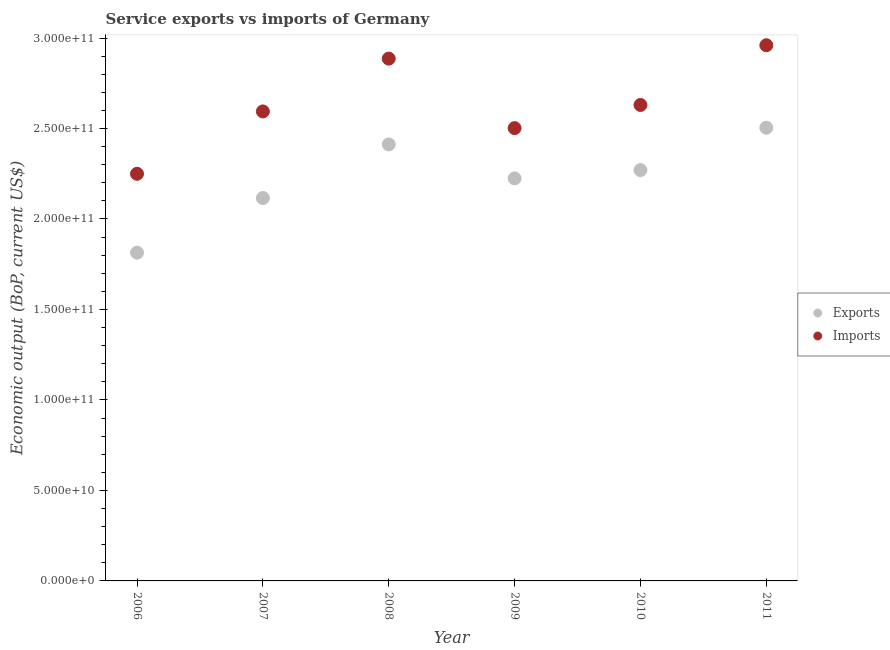How many different coloured dotlines are there?
Offer a terse response. 2. Is the number of dotlines equal to the number of legend labels?
Keep it short and to the point. Yes. What is the amount of service exports in 2010?
Your response must be concise. 2.27e+11. Across all years, what is the maximum amount of service exports?
Provide a short and direct response. 2.50e+11. Across all years, what is the minimum amount of service exports?
Provide a short and direct response. 1.81e+11. What is the total amount of service exports in the graph?
Make the answer very short. 1.33e+12. What is the difference between the amount of service exports in 2007 and that in 2008?
Your response must be concise. -2.96e+1. What is the difference between the amount of service imports in 2010 and the amount of service exports in 2009?
Provide a succinct answer. 4.06e+1. What is the average amount of service exports per year?
Keep it short and to the point. 2.22e+11. In the year 2010, what is the difference between the amount of service exports and amount of service imports?
Make the answer very short. -3.60e+1. What is the ratio of the amount of service exports in 2009 to that in 2010?
Provide a succinct answer. 0.98. Is the amount of service imports in 2006 less than that in 2009?
Offer a very short reply. Yes. What is the difference between the highest and the second highest amount of service imports?
Ensure brevity in your answer.  7.39e+09. What is the difference between the highest and the lowest amount of service exports?
Your answer should be compact. 6.91e+1. Is the sum of the amount of service exports in 2007 and 2009 greater than the maximum amount of service imports across all years?
Ensure brevity in your answer.  Yes. Does the graph contain grids?
Your answer should be compact. No. How many legend labels are there?
Offer a terse response. 2. How are the legend labels stacked?
Offer a terse response. Vertical. What is the title of the graph?
Your answer should be compact. Service exports vs imports of Germany. What is the label or title of the Y-axis?
Your response must be concise. Economic output (BoP, current US$). What is the Economic output (BoP, current US$) in Exports in 2006?
Provide a short and direct response. 1.81e+11. What is the Economic output (BoP, current US$) of Imports in 2006?
Ensure brevity in your answer.  2.25e+11. What is the Economic output (BoP, current US$) in Exports in 2007?
Provide a succinct answer. 2.12e+11. What is the Economic output (BoP, current US$) of Imports in 2007?
Offer a terse response. 2.59e+11. What is the Economic output (BoP, current US$) of Exports in 2008?
Provide a short and direct response. 2.41e+11. What is the Economic output (BoP, current US$) of Imports in 2008?
Your answer should be compact. 2.89e+11. What is the Economic output (BoP, current US$) in Exports in 2009?
Your response must be concise. 2.22e+11. What is the Economic output (BoP, current US$) of Imports in 2009?
Provide a short and direct response. 2.50e+11. What is the Economic output (BoP, current US$) of Exports in 2010?
Offer a very short reply. 2.27e+11. What is the Economic output (BoP, current US$) of Imports in 2010?
Make the answer very short. 2.63e+11. What is the Economic output (BoP, current US$) in Exports in 2011?
Make the answer very short. 2.50e+11. What is the Economic output (BoP, current US$) of Imports in 2011?
Provide a succinct answer. 2.96e+11. Across all years, what is the maximum Economic output (BoP, current US$) of Exports?
Make the answer very short. 2.50e+11. Across all years, what is the maximum Economic output (BoP, current US$) of Imports?
Your answer should be compact. 2.96e+11. Across all years, what is the minimum Economic output (BoP, current US$) in Exports?
Ensure brevity in your answer.  1.81e+11. Across all years, what is the minimum Economic output (BoP, current US$) of Imports?
Your answer should be very brief. 2.25e+11. What is the total Economic output (BoP, current US$) in Exports in the graph?
Provide a succinct answer. 1.33e+12. What is the total Economic output (BoP, current US$) of Imports in the graph?
Your answer should be very brief. 1.58e+12. What is the difference between the Economic output (BoP, current US$) of Exports in 2006 and that in 2007?
Make the answer very short. -3.02e+1. What is the difference between the Economic output (BoP, current US$) of Imports in 2006 and that in 2007?
Provide a short and direct response. -3.45e+1. What is the difference between the Economic output (BoP, current US$) in Exports in 2006 and that in 2008?
Ensure brevity in your answer.  -5.98e+1. What is the difference between the Economic output (BoP, current US$) of Imports in 2006 and that in 2008?
Your answer should be compact. -6.36e+1. What is the difference between the Economic output (BoP, current US$) of Exports in 2006 and that in 2009?
Keep it short and to the point. -4.11e+1. What is the difference between the Economic output (BoP, current US$) in Imports in 2006 and that in 2009?
Your answer should be very brief. -2.52e+1. What is the difference between the Economic output (BoP, current US$) in Exports in 2006 and that in 2010?
Offer a terse response. -4.56e+1. What is the difference between the Economic output (BoP, current US$) in Imports in 2006 and that in 2010?
Ensure brevity in your answer.  -3.80e+1. What is the difference between the Economic output (BoP, current US$) of Exports in 2006 and that in 2011?
Your answer should be very brief. -6.91e+1. What is the difference between the Economic output (BoP, current US$) of Imports in 2006 and that in 2011?
Give a very brief answer. -7.10e+1. What is the difference between the Economic output (BoP, current US$) in Exports in 2007 and that in 2008?
Your answer should be compact. -2.96e+1. What is the difference between the Economic output (BoP, current US$) of Imports in 2007 and that in 2008?
Your answer should be very brief. -2.92e+1. What is the difference between the Economic output (BoP, current US$) of Exports in 2007 and that in 2009?
Your response must be concise. -1.09e+1. What is the difference between the Economic output (BoP, current US$) in Imports in 2007 and that in 2009?
Make the answer very short. 9.21e+09. What is the difference between the Economic output (BoP, current US$) in Exports in 2007 and that in 2010?
Offer a very short reply. -1.54e+1. What is the difference between the Economic output (BoP, current US$) in Imports in 2007 and that in 2010?
Keep it short and to the point. -3.58e+09. What is the difference between the Economic output (BoP, current US$) of Exports in 2007 and that in 2011?
Your answer should be very brief. -3.88e+1. What is the difference between the Economic output (BoP, current US$) in Imports in 2007 and that in 2011?
Offer a very short reply. -3.66e+1. What is the difference between the Economic output (BoP, current US$) in Exports in 2008 and that in 2009?
Offer a terse response. 1.88e+1. What is the difference between the Economic output (BoP, current US$) of Imports in 2008 and that in 2009?
Give a very brief answer. 3.84e+1. What is the difference between the Economic output (BoP, current US$) of Exports in 2008 and that in 2010?
Your response must be concise. 1.42e+1. What is the difference between the Economic output (BoP, current US$) of Imports in 2008 and that in 2010?
Your answer should be compact. 2.56e+1. What is the difference between the Economic output (BoP, current US$) in Exports in 2008 and that in 2011?
Your response must be concise. -9.24e+09. What is the difference between the Economic output (BoP, current US$) in Imports in 2008 and that in 2011?
Your response must be concise. -7.39e+09. What is the difference between the Economic output (BoP, current US$) in Exports in 2009 and that in 2010?
Your answer should be very brief. -4.57e+09. What is the difference between the Economic output (BoP, current US$) of Imports in 2009 and that in 2010?
Offer a very short reply. -1.28e+1. What is the difference between the Economic output (BoP, current US$) of Exports in 2009 and that in 2011?
Give a very brief answer. -2.80e+1. What is the difference between the Economic output (BoP, current US$) in Imports in 2009 and that in 2011?
Offer a very short reply. -4.58e+1. What is the difference between the Economic output (BoP, current US$) in Exports in 2010 and that in 2011?
Your response must be concise. -2.34e+1. What is the difference between the Economic output (BoP, current US$) of Imports in 2010 and that in 2011?
Offer a very short reply. -3.30e+1. What is the difference between the Economic output (BoP, current US$) of Exports in 2006 and the Economic output (BoP, current US$) of Imports in 2007?
Give a very brief answer. -7.80e+1. What is the difference between the Economic output (BoP, current US$) of Exports in 2006 and the Economic output (BoP, current US$) of Imports in 2008?
Give a very brief answer. -1.07e+11. What is the difference between the Economic output (BoP, current US$) in Exports in 2006 and the Economic output (BoP, current US$) in Imports in 2009?
Your answer should be compact. -6.88e+1. What is the difference between the Economic output (BoP, current US$) of Exports in 2006 and the Economic output (BoP, current US$) of Imports in 2010?
Your answer should be very brief. -8.16e+1. What is the difference between the Economic output (BoP, current US$) in Exports in 2006 and the Economic output (BoP, current US$) in Imports in 2011?
Make the answer very short. -1.15e+11. What is the difference between the Economic output (BoP, current US$) in Exports in 2007 and the Economic output (BoP, current US$) in Imports in 2008?
Your answer should be very brief. -7.70e+1. What is the difference between the Economic output (BoP, current US$) of Exports in 2007 and the Economic output (BoP, current US$) of Imports in 2009?
Make the answer very short. -3.86e+1. What is the difference between the Economic output (BoP, current US$) in Exports in 2007 and the Economic output (BoP, current US$) in Imports in 2010?
Your answer should be very brief. -5.14e+1. What is the difference between the Economic output (BoP, current US$) in Exports in 2007 and the Economic output (BoP, current US$) in Imports in 2011?
Your answer should be compact. -8.44e+1. What is the difference between the Economic output (BoP, current US$) of Exports in 2008 and the Economic output (BoP, current US$) of Imports in 2009?
Keep it short and to the point. -9.02e+09. What is the difference between the Economic output (BoP, current US$) of Exports in 2008 and the Economic output (BoP, current US$) of Imports in 2010?
Give a very brief answer. -2.18e+1. What is the difference between the Economic output (BoP, current US$) of Exports in 2008 and the Economic output (BoP, current US$) of Imports in 2011?
Your answer should be very brief. -5.48e+1. What is the difference between the Economic output (BoP, current US$) of Exports in 2009 and the Economic output (BoP, current US$) of Imports in 2010?
Make the answer very short. -4.06e+1. What is the difference between the Economic output (BoP, current US$) in Exports in 2009 and the Economic output (BoP, current US$) in Imports in 2011?
Make the answer very short. -7.36e+1. What is the difference between the Economic output (BoP, current US$) in Exports in 2010 and the Economic output (BoP, current US$) in Imports in 2011?
Your answer should be very brief. -6.90e+1. What is the average Economic output (BoP, current US$) in Exports per year?
Your response must be concise. 2.22e+11. What is the average Economic output (BoP, current US$) in Imports per year?
Your answer should be very brief. 2.64e+11. In the year 2006, what is the difference between the Economic output (BoP, current US$) of Exports and Economic output (BoP, current US$) of Imports?
Your response must be concise. -4.36e+1. In the year 2007, what is the difference between the Economic output (BoP, current US$) in Exports and Economic output (BoP, current US$) in Imports?
Give a very brief answer. -4.78e+1. In the year 2008, what is the difference between the Economic output (BoP, current US$) of Exports and Economic output (BoP, current US$) of Imports?
Offer a very short reply. -4.74e+1. In the year 2009, what is the difference between the Economic output (BoP, current US$) in Exports and Economic output (BoP, current US$) in Imports?
Keep it short and to the point. -2.78e+1. In the year 2010, what is the difference between the Economic output (BoP, current US$) of Exports and Economic output (BoP, current US$) of Imports?
Ensure brevity in your answer.  -3.60e+1. In the year 2011, what is the difference between the Economic output (BoP, current US$) of Exports and Economic output (BoP, current US$) of Imports?
Your response must be concise. -4.56e+1. What is the ratio of the Economic output (BoP, current US$) in Exports in 2006 to that in 2007?
Provide a short and direct response. 0.86. What is the ratio of the Economic output (BoP, current US$) in Imports in 2006 to that in 2007?
Provide a succinct answer. 0.87. What is the ratio of the Economic output (BoP, current US$) in Exports in 2006 to that in 2008?
Your answer should be very brief. 0.75. What is the ratio of the Economic output (BoP, current US$) of Imports in 2006 to that in 2008?
Keep it short and to the point. 0.78. What is the ratio of the Economic output (BoP, current US$) of Exports in 2006 to that in 2009?
Keep it short and to the point. 0.82. What is the ratio of the Economic output (BoP, current US$) in Imports in 2006 to that in 2009?
Your response must be concise. 0.9. What is the ratio of the Economic output (BoP, current US$) in Exports in 2006 to that in 2010?
Your answer should be very brief. 0.8. What is the ratio of the Economic output (BoP, current US$) in Imports in 2006 to that in 2010?
Offer a very short reply. 0.86. What is the ratio of the Economic output (BoP, current US$) in Exports in 2006 to that in 2011?
Provide a short and direct response. 0.72. What is the ratio of the Economic output (BoP, current US$) in Imports in 2006 to that in 2011?
Give a very brief answer. 0.76. What is the ratio of the Economic output (BoP, current US$) of Exports in 2007 to that in 2008?
Make the answer very short. 0.88. What is the ratio of the Economic output (BoP, current US$) in Imports in 2007 to that in 2008?
Offer a very short reply. 0.9. What is the ratio of the Economic output (BoP, current US$) in Exports in 2007 to that in 2009?
Give a very brief answer. 0.95. What is the ratio of the Economic output (BoP, current US$) in Imports in 2007 to that in 2009?
Make the answer very short. 1.04. What is the ratio of the Economic output (BoP, current US$) in Exports in 2007 to that in 2010?
Your answer should be very brief. 0.93. What is the ratio of the Economic output (BoP, current US$) in Imports in 2007 to that in 2010?
Your answer should be compact. 0.99. What is the ratio of the Economic output (BoP, current US$) of Exports in 2007 to that in 2011?
Provide a short and direct response. 0.84. What is the ratio of the Economic output (BoP, current US$) in Imports in 2007 to that in 2011?
Make the answer very short. 0.88. What is the ratio of the Economic output (BoP, current US$) of Exports in 2008 to that in 2009?
Your response must be concise. 1.08. What is the ratio of the Economic output (BoP, current US$) in Imports in 2008 to that in 2009?
Offer a terse response. 1.15. What is the ratio of the Economic output (BoP, current US$) in Exports in 2008 to that in 2010?
Make the answer very short. 1.06. What is the ratio of the Economic output (BoP, current US$) of Imports in 2008 to that in 2010?
Provide a short and direct response. 1.1. What is the ratio of the Economic output (BoP, current US$) in Exports in 2008 to that in 2011?
Ensure brevity in your answer.  0.96. What is the ratio of the Economic output (BoP, current US$) in Exports in 2009 to that in 2010?
Provide a succinct answer. 0.98. What is the ratio of the Economic output (BoP, current US$) of Imports in 2009 to that in 2010?
Offer a terse response. 0.95. What is the ratio of the Economic output (BoP, current US$) in Exports in 2009 to that in 2011?
Make the answer very short. 0.89. What is the ratio of the Economic output (BoP, current US$) in Imports in 2009 to that in 2011?
Keep it short and to the point. 0.85. What is the ratio of the Economic output (BoP, current US$) in Exports in 2010 to that in 2011?
Offer a very short reply. 0.91. What is the ratio of the Economic output (BoP, current US$) in Imports in 2010 to that in 2011?
Your answer should be compact. 0.89. What is the difference between the highest and the second highest Economic output (BoP, current US$) of Exports?
Your answer should be compact. 9.24e+09. What is the difference between the highest and the second highest Economic output (BoP, current US$) in Imports?
Provide a short and direct response. 7.39e+09. What is the difference between the highest and the lowest Economic output (BoP, current US$) of Exports?
Your response must be concise. 6.91e+1. What is the difference between the highest and the lowest Economic output (BoP, current US$) of Imports?
Give a very brief answer. 7.10e+1. 